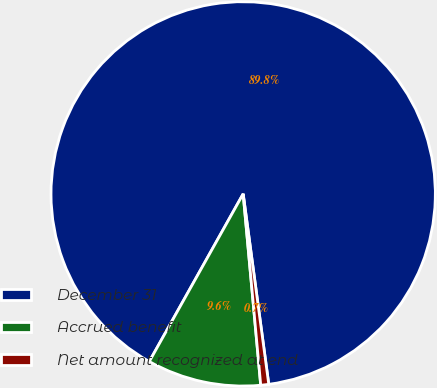Convert chart. <chart><loc_0><loc_0><loc_500><loc_500><pie_chart><fcel>December 31<fcel>Accrued benefit<fcel>Net amount recognized at end<nl><fcel>89.76%<fcel>9.58%<fcel>0.67%<nl></chart> 